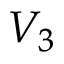Convert formula to latex. <formula><loc_0><loc_0><loc_500><loc_500>V _ { 3 }</formula> 